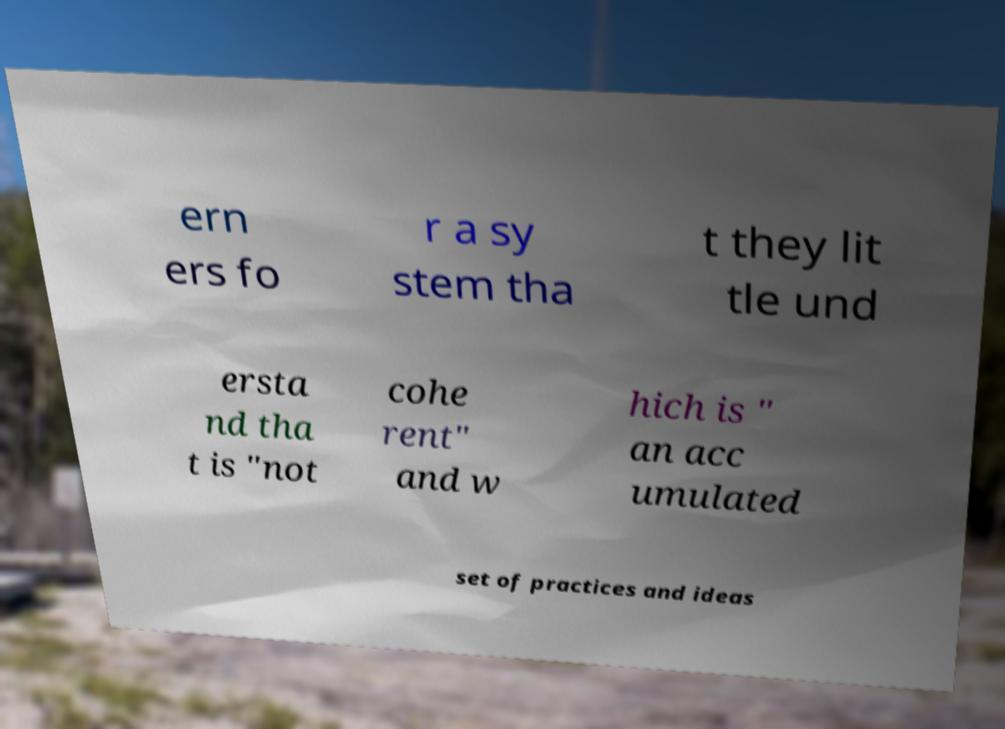Could you extract and type out the text from this image? ern ers fo r a sy stem tha t they lit tle und ersta nd tha t is "not cohe rent" and w hich is " an acc umulated set of practices and ideas 